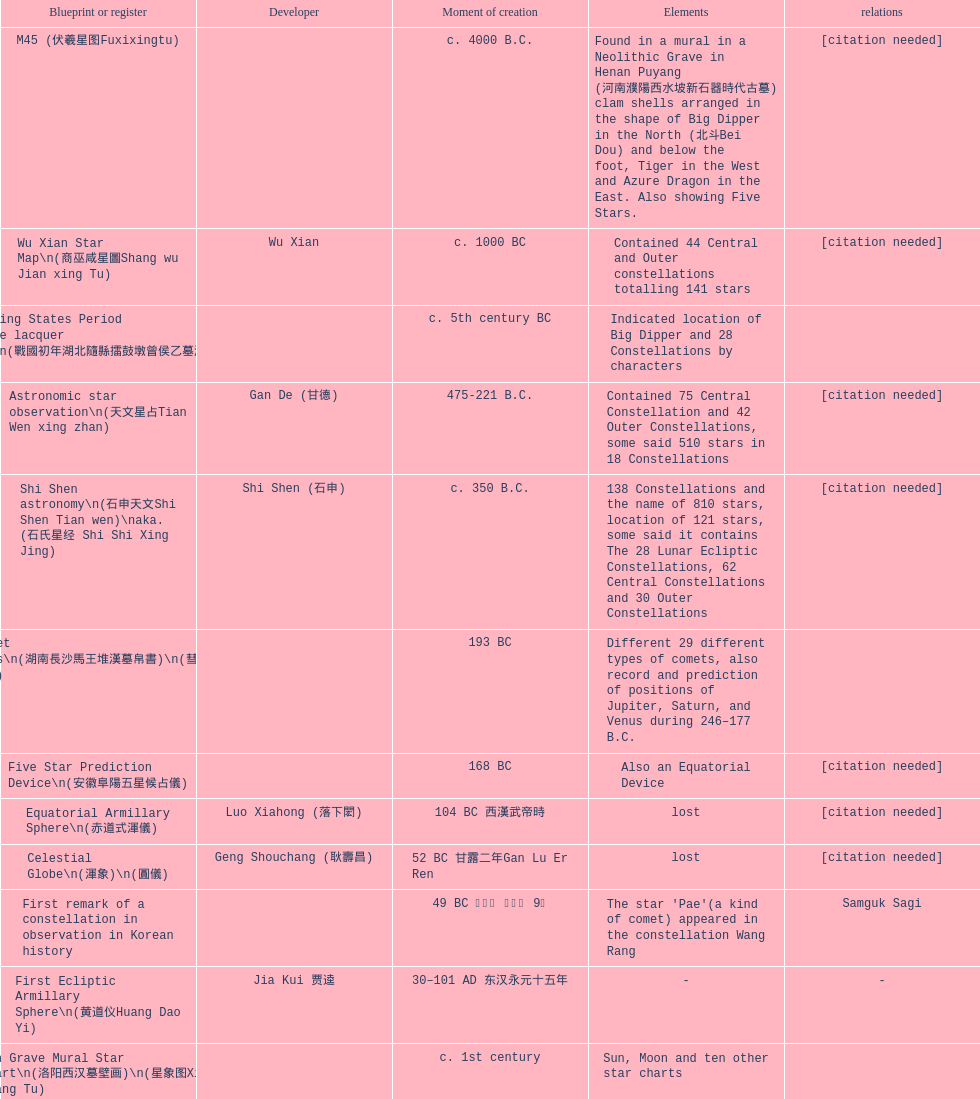When was the first map or catalog created? C. 4000 b.c. 